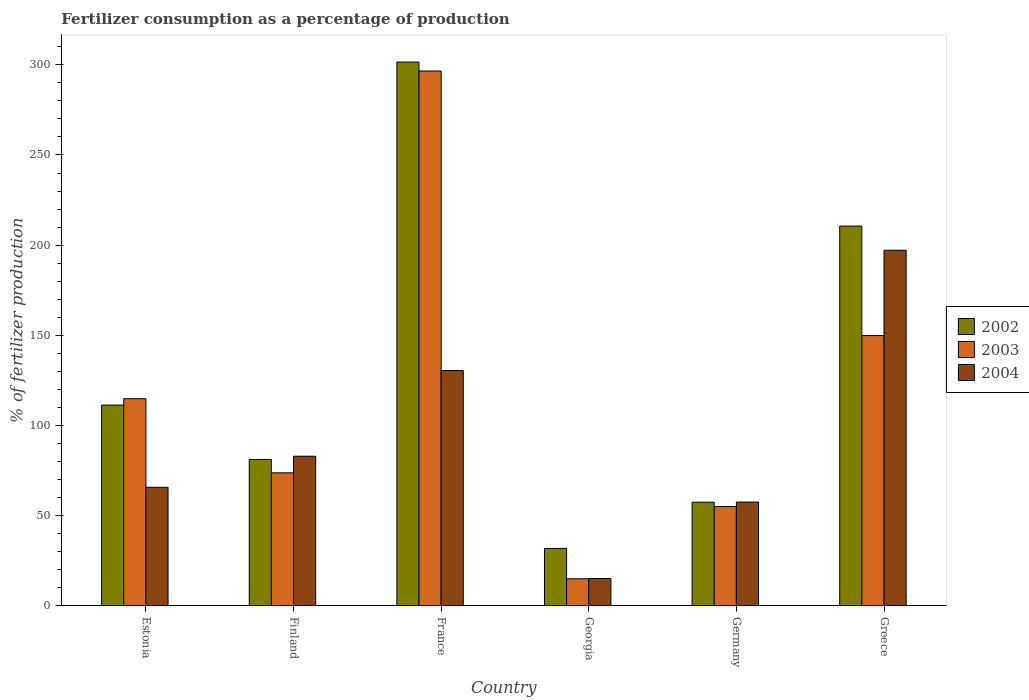How many different coloured bars are there?
Provide a succinct answer. 3. Are the number of bars on each tick of the X-axis equal?
Your answer should be compact. Yes. How many bars are there on the 4th tick from the right?
Your answer should be compact. 3. What is the percentage of fertilizers consumed in 2004 in Germany?
Your answer should be compact. 57.52. Across all countries, what is the maximum percentage of fertilizers consumed in 2002?
Provide a short and direct response. 301.53. Across all countries, what is the minimum percentage of fertilizers consumed in 2002?
Make the answer very short. 31.81. In which country was the percentage of fertilizers consumed in 2002 maximum?
Your response must be concise. France. In which country was the percentage of fertilizers consumed in 2002 minimum?
Keep it short and to the point. Georgia. What is the total percentage of fertilizers consumed in 2002 in the graph?
Make the answer very short. 793.79. What is the difference between the percentage of fertilizers consumed in 2004 in Estonia and that in France?
Make the answer very short. -64.72. What is the difference between the percentage of fertilizers consumed in 2003 in Greece and the percentage of fertilizers consumed in 2002 in Georgia?
Offer a terse response. 118.05. What is the average percentage of fertilizers consumed in 2002 per country?
Your answer should be compact. 132.3. What is the difference between the percentage of fertilizers consumed of/in 2003 and percentage of fertilizers consumed of/in 2004 in Germany?
Your response must be concise. -2.5. In how many countries, is the percentage of fertilizers consumed in 2002 greater than 300 %?
Give a very brief answer. 1. What is the ratio of the percentage of fertilizers consumed in 2002 in Estonia to that in Finland?
Provide a short and direct response. 1.37. Is the difference between the percentage of fertilizers consumed in 2003 in Estonia and Georgia greater than the difference between the percentage of fertilizers consumed in 2004 in Estonia and Georgia?
Provide a succinct answer. Yes. What is the difference between the highest and the second highest percentage of fertilizers consumed in 2004?
Your response must be concise. 47.53. What is the difference between the highest and the lowest percentage of fertilizers consumed in 2004?
Your answer should be very brief. 182.06. In how many countries, is the percentage of fertilizers consumed in 2004 greater than the average percentage of fertilizers consumed in 2004 taken over all countries?
Provide a succinct answer. 2. What does the 2nd bar from the right in Germany represents?
Keep it short and to the point. 2003. Is it the case that in every country, the sum of the percentage of fertilizers consumed in 2003 and percentage of fertilizers consumed in 2004 is greater than the percentage of fertilizers consumed in 2002?
Give a very brief answer. No. How many bars are there?
Offer a very short reply. 18. Are the values on the major ticks of Y-axis written in scientific E-notation?
Your answer should be compact. No. Does the graph contain any zero values?
Make the answer very short. No. Where does the legend appear in the graph?
Your answer should be compact. Center right. How many legend labels are there?
Offer a terse response. 3. How are the legend labels stacked?
Provide a short and direct response. Vertical. What is the title of the graph?
Offer a very short reply. Fertilizer consumption as a percentage of production. Does "1979" appear as one of the legend labels in the graph?
Give a very brief answer. No. What is the label or title of the X-axis?
Give a very brief answer. Country. What is the label or title of the Y-axis?
Your answer should be compact. % of fertilizer production. What is the % of fertilizer production in 2002 in Estonia?
Provide a short and direct response. 111.3. What is the % of fertilizer production of 2003 in Estonia?
Offer a very short reply. 114.85. What is the % of fertilizer production of 2004 in Estonia?
Your answer should be compact. 65.74. What is the % of fertilizer production of 2002 in Finland?
Ensure brevity in your answer.  81.14. What is the % of fertilizer production in 2003 in Finland?
Make the answer very short. 73.73. What is the % of fertilizer production in 2004 in Finland?
Keep it short and to the point. 82.93. What is the % of fertilizer production in 2002 in France?
Your response must be concise. 301.53. What is the % of fertilizer production of 2003 in France?
Your answer should be very brief. 296.56. What is the % of fertilizer production in 2004 in France?
Your response must be concise. 130.46. What is the % of fertilizer production of 2002 in Georgia?
Keep it short and to the point. 31.81. What is the % of fertilizer production of 2003 in Georgia?
Provide a short and direct response. 14.99. What is the % of fertilizer production in 2004 in Georgia?
Your answer should be compact. 15.12. What is the % of fertilizer production of 2002 in Germany?
Your response must be concise. 57.44. What is the % of fertilizer production of 2003 in Germany?
Keep it short and to the point. 55.03. What is the % of fertilizer production in 2004 in Germany?
Offer a very short reply. 57.52. What is the % of fertilizer production in 2002 in Greece?
Your answer should be compact. 210.57. What is the % of fertilizer production of 2003 in Greece?
Make the answer very short. 149.85. What is the % of fertilizer production of 2004 in Greece?
Give a very brief answer. 197.18. Across all countries, what is the maximum % of fertilizer production in 2002?
Provide a short and direct response. 301.53. Across all countries, what is the maximum % of fertilizer production of 2003?
Provide a short and direct response. 296.56. Across all countries, what is the maximum % of fertilizer production of 2004?
Ensure brevity in your answer.  197.18. Across all countries, what is the minimum % of fertilizer production in 2002?
Offer a terse response. 31.81. Across all countries, what is the minimum % of fertilizer production of 2003?
Offer a very short reply. 14.99. Across all countries, what is the minimum % of fertilizer production of 2004?
Offer a terse response. 15.12. What is the total % of fertilizer production in 2002 in the graph?
Ensure brevity in your answer.  793.79. What is the total % of fertilizer production of 2003 in the graph?
Offer a terse response. 705.01. What is the total % of fertilizer production of 2004 in the graph?
Provide a succinct answer. 548.95. What is the difference between the % of fertilizer production in 2002 in Estonia and that in Finland?
Ensure brevity in your answer.  30.17. What is the difference between the % of fertilizer production of 2003 in Estonia and that in Finland?
Make the answer very short. 41.12. What is the difference between the % of fertilizer production of 2004 in Estonia and that in Finland?
Provide a succinct answer. -17.19. What is the difference between the % of fertilizer production in 2002 in Estonia and that in France?
Keep it short and to the point. -190.22. What is the difference between the % of fertilizer production in 2003 in Estonia and that in France?
Provide a short and direct response. -181.71. What is the difference between the % of fertilizer production of 2004 in Estonia and that in France?
Your answer should be very brief. -64.72. What is the difference between the % of fertilizer production of 2002 in Estonia and that in Georgia?
Ensure brevity in your answer.  79.5. What is the difference between the % of fertilizer production in 2003 in Estonia and that in Georgia?
Ensure brevity in your answer.  99.86. What is the difference between the % of fertilizer production of 2004 in Estonia and that in Georgia?
Offer a terse response. 50.62. What is the difference between the % of fertilizer production in 2002 in Estonia and that in Germany?
Ensure brevity in your answer.  53.86. What is the difference between the % of fertilizer production of 2003 in Estonia and that in Germany?
Give a very brief answer. 59.82. What is the difference between the % of fertilizer production of 2004 in Estonia and that in Germany?
Provide a succinct answer. 8.21. What is the difference between the % of fertilizer production in 2002 in Estonia and that in Greece?
Your response must be concise. -99.27. What is the difference between the % of fertilizer production in 2003 in Estonia and that in Greece?
Keep it short and to the point. -35. What is the difference between the % of fertilizer production of 2004 in Estonia and that in Greece?
Offer a very short reply. -131.44. What is the difference between the % of fertilizer production of 2002 in Finland and that in France?
Give a very brief answer. -220.39. What is the difference between the % of fertilizer production in 2003 in Finland and that in France?
Offer a terse response. -222.83. What is the difference between the % of fertilizer production of 2004 in Finland and that in France?
Offer a terse response. -47.53. What is the difference between the % of fertilizer production of 2002 in Finland and that in Georgia?
Your response must be concise. 49.33. What is the difference between the % of fertilizer production of 2003 in Finland and that in Georgia?
Provide a succinct answer. 58.75. What is the difference between the % of fertilizer production of 2004 in Finland and that in Georgia?
Offer a very short reply. 67.81. What is the difference between the % of fertilizer production of 2002 in Finland and that in Germany?
Ensure brevity in your answer.  23.7. What is the difference between the % of fertilizer production in 2003 in Finland and that in Germany?
Give a very brief answer. 18.71. What is the difference between the % of fertilizer production of 2004 in Finland and that in Germany?
Keep it short and to the point. 25.41. What is the difference between the % of fertilizer production of 2002 in Finland and that in Greece?
Ensure brevity in your answer.  -129.44. What is the difference between the % of fertilizer production in 2003 in Finland and that in Greece?
Ensure brevity in your answer.  -76.12. What is the difference between the % of fertilizer production of 2004 in Finland and that in Greece?
Ensure brevity in your answer.  -114.24. What is the difference between the % of fertilizer production of 2002 in France and that in Georgia?
Provide a succinct answer. 269.72. What is the difference between the % of fertilizer production of 2003 in France and that in Georgia?
Your answer should be compact. 281.58. What is the difference between the % of fertilizer production in 2004 in France and that in Georgia?
Provide a short and direct response. 115.34. What is the difference between the % of fertilizer production of 2002 in France and that in Germany?
Keep it short and to the point. 244.09. What is the difference between the % of fertilizer production of 2003 in France and that in Germany?
Make the answer very short. 241.54. What is the difference between the % of fertilizer production in 2004 in France and that in Germany?
Ensure brevity in your answer.  72.94. What is the difference between the % of fertilizer production of 2002 in France and that in Greece?
Offer a terse response. 90.96. What is the difference between the % of fertilizer production of 2003 in France and that in Greece?
Keep it short and to the point. 146.71. What is the difference between the % of fertilizer production in 2004 in France and that in Greece?
Make the answer very short. -66.72. What is the difference between the % of fertilizer production of 2002 in Georgia and that in Germany?
Ensure brevity in your answer.  -25.63. What is the difference between the % of fertilizer production in 2003 in Georgia and that in Germany?
Your response must be concise. -40.04. What is the difference between the % of fertilizer production in 2004 in Georgia and that in Germany?
Provide a succinct answer. -42.4. What is the difference between the % of fertilizer production of 2002 in Georgia and that in Greece?
Offer a terse response. -178.77. What is the difference between the % of fertilizer production of 2003 in Georgia and that in Greece?
Keep it short and to the point. -134.87. What is the difference between the % of fertilizer production of 2004 in Georgia and that in Greece?
Offer a terse response. -182.06. What is the difference between the % of fertilizer production in 2002 in Germany and that in Greece?
Give a very brief answer. -153.13. What is the difference between the % of fertilizer production in 2003 in Germany and that in Greece?
Offer a terse response. -94.83. What is the difference between the % of fertilizer production in 2004 in Germany and that in Greece?
Your answer should be compact. -139.65. What is the difference between the % of fertilizer production of 2002 in Estonia and the % of fertilizer production of 2003 in Finland?
Offer a terse response. 37.57. What is the difference between the % of fertilizer production in 2002 in Estonia and the % of fertilizer production in 2004 in Finland?
Keep it short and to the point. 28.37. What is the difference between the % of fertilizer production in 2003 in Estonia and the % of fertilizer production in 2004 in Finland?
Keep it short and to the point. 31.92. What is the difference between the % of fertilizer production in 2002 in Estonia and the % of fertilizer production in 2003 in France?
Offer a terse response. -185.26. What is the difference between the % of fertilizer production of 2002 in Estonia and the % of fertilizer production of 2004 in France?
Give a very brief answer. -19.16. What is the difference between the % of fertilizer production in 2003 in Estonia and the % of fertilizer production in 2004 in France?
Offer a very short reply. -15.61. What is the difference between the % of fertilizer production in 2002 in Estonia and the % of fertilizer production in 2003 in Georgia?
Provide a succinct answer. 96.32. What is the difference between the % of fertilizer production of 2002 in Estonia and the % of fertilizer production of 2004 in Georgia?
Give a very brief answer. 96.19. What is the difference between the % of fertilizer production in 2003 in Estonia and the % of fertilizer production in 2004 in Georgia?
Your response must be concise. 99.73. What is the difference between the % of fertilizer production of 2002 in Estonia and the % of fertilizer production of 2003 in Germany?
Offer a very short reply. 56.28. What is the difference between the % of fertilizer production in 2002 in Estonia and the % of fertilizer production in 2004 in Germany?
Offer a terse response. 53.78. What is the difference between the % of fertilizer production of 2003 in Estonia and the % of fertilizer production of 2004 in Germany?
Your response must be concise. 57.33. What is the difference between the % of fertilizer production in 2002 in Estonia and the % of fertilizer production in 2003 in Greece?
Your answer should be very brief. -38.55. What is the difference between the % of fertilizer production in 2002 in Estonia and the % of fertilizer production in 2004 in Greece?
Provide a short and direct response. -85.87. What is the difference between the % of fertilizer production in 2003 in Estonia and the % of fertilizer production in 2004 in Greece?
Make the answer very short. -82.33. What is the difference between the % of fertilizer production of 2002 in Finland and the % of fertilizer production of 2003 in France?
Make the answer very short. -215.43. What is the difference between the % of fertilizer production in 2002 in Finland and the % of fertilizer production in 2004 in France?
Keep it short and to the point. -49.32. What is the difference between the % of fertilizer production in 2003 in Finland and the % of fertilizer production in 2004 in France?
Offer a terse response. -56.73. What is the difference between the % of fertilizer production of 2002 in Finland and the % of fertilizer production of 2003 in Georgia?
Your response must be concise. 66.15. What is the difference between the % of fertilizer production of 2002 in Finland and the % of fertilizer production of 2004 in Georgia?
Provide a short and direct response. 66.02. What is the difference between the % of fertilizer production in 2003 in Finland and the % of fertilizer production in 2004 in Georgia?
Your response must be concise. 58.61. What is the difference between the % of fertilizer production in 2002 in Finland and the % of fertilizer production in 2003 in Germany?
Your answer should be very brief. 26.11. What is the difference between the % of fertilizer production of 2002 in Finland and the % of fertilizer production of 2004 in Germany?
Your answer should be compact. 23.61. What is the difference between the % of fertilizer production in 2003 in Finland and the % of fertilizer production in 2004 in Germany?
Keep it short and to the point. 16.21. What is the difference between the % of fertilizer production in 2002 in Finland and the % of fertilizer production in 2003 in Greece?
Offer a very short reply. -68.72. What is the difference between the % of fertilizer production of 2002 in Finland and the % of fertilizer production of 2004 in Greece?
Offer a very short reply. -116.04. What is the difference between the % of fertilizer production in 2003 in Finland and the % of fertilizer production in 2004 in Greece?
Make the answer very short. -123.44. What is the difference between the % of fertilizer production of 2002 in France and the % of fertilizer production of 2003 in Georgia?
Make the answer very short. 286.54. What is the difference between the % of fertilizer production in 2002 in France and the % of fertilizer production in 2004 in Georgia?
Provide a short and direct response. 286.41. What is the difference between the % of fertilizer production in 2003 in France and the % of fertilizer production in 2004 in Georgia?
Provide a short and direct response. 281.45. What is the difference between the % of fertilizer production of 2002 in France and the % of fertilizer production of 2003 in Germany?
Offer a terse response. 246.5. What is the difference between the % of fertilizer production in 2002 in France and the % of fertilizer production in 2004 in Germany?
Offer a very short reply. 244.01. What is the difference between the % of fertilizer production of 2003 in France and the % of fertilizer production of 2004 in Germany?
Offer a very short reply. 239.04. What is the difference between the % of fertilizer production of 2002 in France and the % of fertilizer production of 2003 in Greece?
Make the answer very short. 151.67. What is the difference between the % of fertilizer production in 2002 in France and the % of fertilizer production in 2004 in Greece?
Keep it short and to the point. 104.35. What is the difference between the % of fertilizer production of 2003 in France and the % of fertilizer production of 2004 in Greece?
Offer a terse response. 99.39. What is the difference between the % of fertilizer production of 2002 in Georgia and the % of fertilizer production of 2003 in Germany?
Make the answer very short. -23.22. What is the difference between the % of fertilizer production in 2002 in Georgia and the % of fertilizer production in 2004 in Germany?
Your answer should be very brief. -25.72. What is the difference between the % of fertilizer production of 2003 in Georgia and the % of fertilizer production of 2004 in Germany?
Make the answer very short. -42.54. What is the difference between the % of fertilizer production of 2002 in Georgia and the % of fertilizer production of 2003 in Greece?
Keep it short and to the point. -118.05. What is the difference between the % of fertilizer production of 2002 in Georgia and the % of fertilizer production of 2004 in Greece?
Give a very brief answer. -165.37. What is the difference between the % of fertilizer production of 2003 in Georgia and the % of fertilizer production of 2004 in Greece?
Offer a terse response. -182.19. What is the difference between the % of fertilizer production of 2002 in Germany and the % of fertilizer production of 2003 in Greece?
Your answer should be compact. -92.41. What is the difference between the % of fertilizer production of 2002 in Germany and the % of fertilizer production of 2004 in Greece?
Your response must be concise. -139.73. What is the difference between the % of fertilizer production of 2003 in Germany and the % of fertilizer production of 2004 in Greece?
Ensure brevity in your answer.  -142.15. What is the average % of fertilizer production in 2002 per country?
Make the answer very short. 132.3. What is the average % of fertilizer production of 2003 per country?
Your answer should be very brief. 117.5. What is the average % of fertilizer production in 2004 per country?
Provide a succinct answer. 91.49. What is the difference between the % of fertilizer production of 2002 and % of fertilizer production of 2003 in Estonia?
Provide a short and direct response. -3.55. What is the difference between the % of fertilizer production of 2002 and % of fertilizer production of 2004 in Estonia?
Your answer should be compact. 45.57. What is the difference between the % of fertilizer production of 2003 and % of fertilizer production of 2004 in Estonia?
Keep it short and to the point. 49.11. What is the difference between the % of fertilizer production in 2002 and % of fertilizer production in 2003 in Finland?
Make the answer very short. 7.41. What is the difference between the % of fertilizer production of 2002 and % of fertilizer production of 2004 in Finland?
Your answer should be very brief. -1.79. What is the difference between the % of fertilizer production of 2003 and % of fertilizer production of 2004 in Finland?
Make the answer very short. -9.2. What is the difference between the % of fertilizer production of 2002 and % of fertilizer production of 2003 in France?
Offer a terse response. 4.96. What is the difference between the % of fertilizer production in 2002 and % of fertilizer production in 2004 in France?
Ensure brevity in your answer.  171.07. What is the difference between the % of fertilizer production of 2003 and % of fertilizer production of 2004 in France?
Make the answer very short. 166.1. What is the difference between the % of fertilizer production in 2002 and % of fertilizer production in 2003 in Georgia?
Give a very brief answer. 16.82. What is the difference between the % of fertilizer production in 2002 and % of fertilizer production in 2004 in Georgia?
Your response must be concise. 16.69. What is the difference between the % of fertilizer production of 2003 and % of fertilizer production of 2004 in Georgia?
Offer a terse response. -0.13. What is the difference between the % of fertilizer production of 2002 and % of fertilizer production of 2003 in Germany?
Make the answer very short. 2.42. What is the difference between the % of fertilizer production in 2002 and % of fertilizer production in 2004 in Germany?
Give a very brief answer. -0.08. What is the difference between the % of fertilizer production of 2003 and % of fertilizer production of 2004 in Germany?
Ensure brevity in your answer.  -2.5. What is the difference between the % of fertilizer production in 2002 and % of fertilizer production in 2003 in Greece?
Ensure brevity in your answer.  60.72. What is the difference between the % of fertilizer production of 2002 and % of fertilizer production of 2004 in Greece?
Ensure brevity in your answer.  13.4. What is the difference between the % of fertilizer production in 2003 and % of fertilizer production in 2004 in Greece?
Ensure brevity in your answer.  -47.32. What is the ratio of the % of fertilizer production of 2002 in Estonia to that in Finland?
Offer a very short reply. 1.37. What is the ratio of the % of fertilizer production of 2003 in Estonia to that in Finland?
Your answer should be compact. 1.56. What is the ratio of the % of fertilizer production of 2004 in Estonia to that in Finland?
Your answer should be compact. 0.79. What is the ratio of the % of fertilizer production in 2002 in Estonia to that in France?
Give a very brief answer. 0.37. What is the ratio of the % of fertilizer production of 2003 in Estonia to that in France?
Keep it short and to the point. 0.39. What is the ratio of the % of fertilizer production of 2004 in Estonia to that in France?
Your answer should be very brief. 0.5. What is the ratio of the % of fertilizer production of 2002 in Estonia to that in Georgia?
Ensure brevity in your answer.  3.5. What is the ratio of the % of fertilizer production in 2003 in Estonia to that in Georgia?
Your answer should be compact. 7.66. What is the ratio of the % of fertilizer production in 2004 in Estonia to that in Georgia?
Offer a terse response. 4.35. What is the ratio of the % of fertilizer production of 2002 in Estonia to that in Germany?
Your response must be concise. 1.94. What is the ratio of the % of fertilizer production of 2003 in Estonia to that in Germany?
Provide a succinct answer. 2.09. What is the ratio of the % of fertilizer production of 2004 in Estonia to that in Germany?
Your answer should be compact. 1.14. What is the ratio of the % of fertilizer production in 2002 in Estonia to that in Greece?
Keep it short and to the point. 0.53. What is the ratio of the % of fertilizer production of 2003 in Estonia to that in Greece?
Provide a short and direct response. 0.77. What is the ratio of the % of fertilizer production of 2004 in Estonia to that in Greece?
Your answer should be compact. 0.33. What is the ratio of the % of fertilizer production in 2002 in Finland to that in France?
Ensure brevity in your answer.  0.27. What is the ratio of the % of fertilizer production in 2003 in Finland to that in France?
Your answer should be compact. 0.25. What is the ratio of the % of fertilizer production of 2004 in Finland to that in France?
Give a very brief answer. 0.64. What is the ratio of the % of fertilizer production of 2002 in Finland to that in Georgia?
Your response must be concise. 2.55. What is the ratio of the % of fertilizer production in 2003 in Finland to that in Georgia?
Offer a very short reply. 4.92. What is the ratio of the % of fertilizer production in 2004 in Finland to that in Georgia?
Keep it short and to the point. 5.49. What is the ratio of the % of fertilizer production in 2002 in Finland to that in Germany?
Your answer should be very brief. 1.41. What is the ratio of the % of fertilizer production of 2003 in Finland to that in Germany?
Keep it short and to the point. 1.34. What is the ratio of the % of fertilizer production in 2004 in Finland to that in Germany?
Ensure brevity in your answer.  1.44. What is the ratio of the % of fertilizer production in 2002 in Finland to that in Greece?
Your response must be concise. 0.39. What is the ratio of the % of fertilizer production of 2003 in Finland to that in Greece?
Offer a terse response. 0.49. What is the ratio of the % of fertilizer production in 2004 in Finland to that in Greece?
Ensure brevity in your answer.  0.42. What is the ratio of the % of fertilizer production in 2002 in France to that in Georgia?
Offer a terse response. 9.48. What is the ratio of the % of fertilizer production of 2003 in France to that in Georgia?
Keep it short and to the point. 19.79. What is the ratio of the % of fertilizer production in 2004 in France to that in Georgia?
Keep it short and to the point. 8.63. What is the ratio of the % of fertilizer production in 2002 in France to that in Germany?
Make the answer very short. 5.25. What is the ratio of the % of fertilizer production of 2003 in France to that in Germany?
Offer a very short reply. 5.39. What is the ratio of the % of fertilizer production of 2004 in France to that in Germany?
Make the answer very short. 2.27. What is the ratio of the % of fertilizer production of 2002 in France to that in Greece?
Provide a succinct answer. 1.43. What is the ratio of the % of fertilizer production of 2003 in France to that in Greece?
Your answer should be very brief. 1.98. What is the ratio of the % of fertilizer production of 2004 in France to that in Greece?
Make the answer very short. 0.66. What is the ratio of the % of fertilizer production in 2002 in Georgia to that in Germany?
Keep it short and to the point. 0.55. What is the ratio of the % of fertilizer production of 2003 in Georgia to that in Germany?
Provide a short and direct response. 0.27. What is the ratio of the % of fertilizer production in 2004 in Georgia to that in Germany?
Offer a very short reply. 0.26. What is the ratio of the % of fertilizer production in 2002 in Georgia to that in Greece?
Your answer should be compact. 0.15. What is the ratio of the % of fertilizer production of 2004 in Georgia to that in Greece?
Offer a terse response. 0.08. What is the ratio of the % of fertilizer production in 2002 in Germany to that in Greece?
Provide a short and direct response. 0.27. What is the ratio of the % of fertilizer production of 2003 in Germany to that in Greece?
Your answer should be compact. 0.37. What is the ratio of the % of fertilizer production of 2004 in Germany to that in Greece?
Give a very brief answer. 0.29. What is the difference between the highest and the second highest % of fertilizer production in 2002?
Provide a short and direct response. 90.96. What is the difference between the highest and the second highest % of fertilizer production of 2003?
Ensure brevity in your answer.  146.71. What is the difference between the highest and the second highest % of fertilizer production of 2004?
Offer a very short reply. 66.72. What is the difference between the highest and the lowest % of fertilizer production in 2002?
Keep it short and to the point. 269.72. What is the difference between the highest and the lowest % of fertilizer production of 2003?
Make the answer very short. 281.58. What is the difference between the highest and the lowest % of fertilizer production of 2004?
Provide a succinct answer. 182.06. 